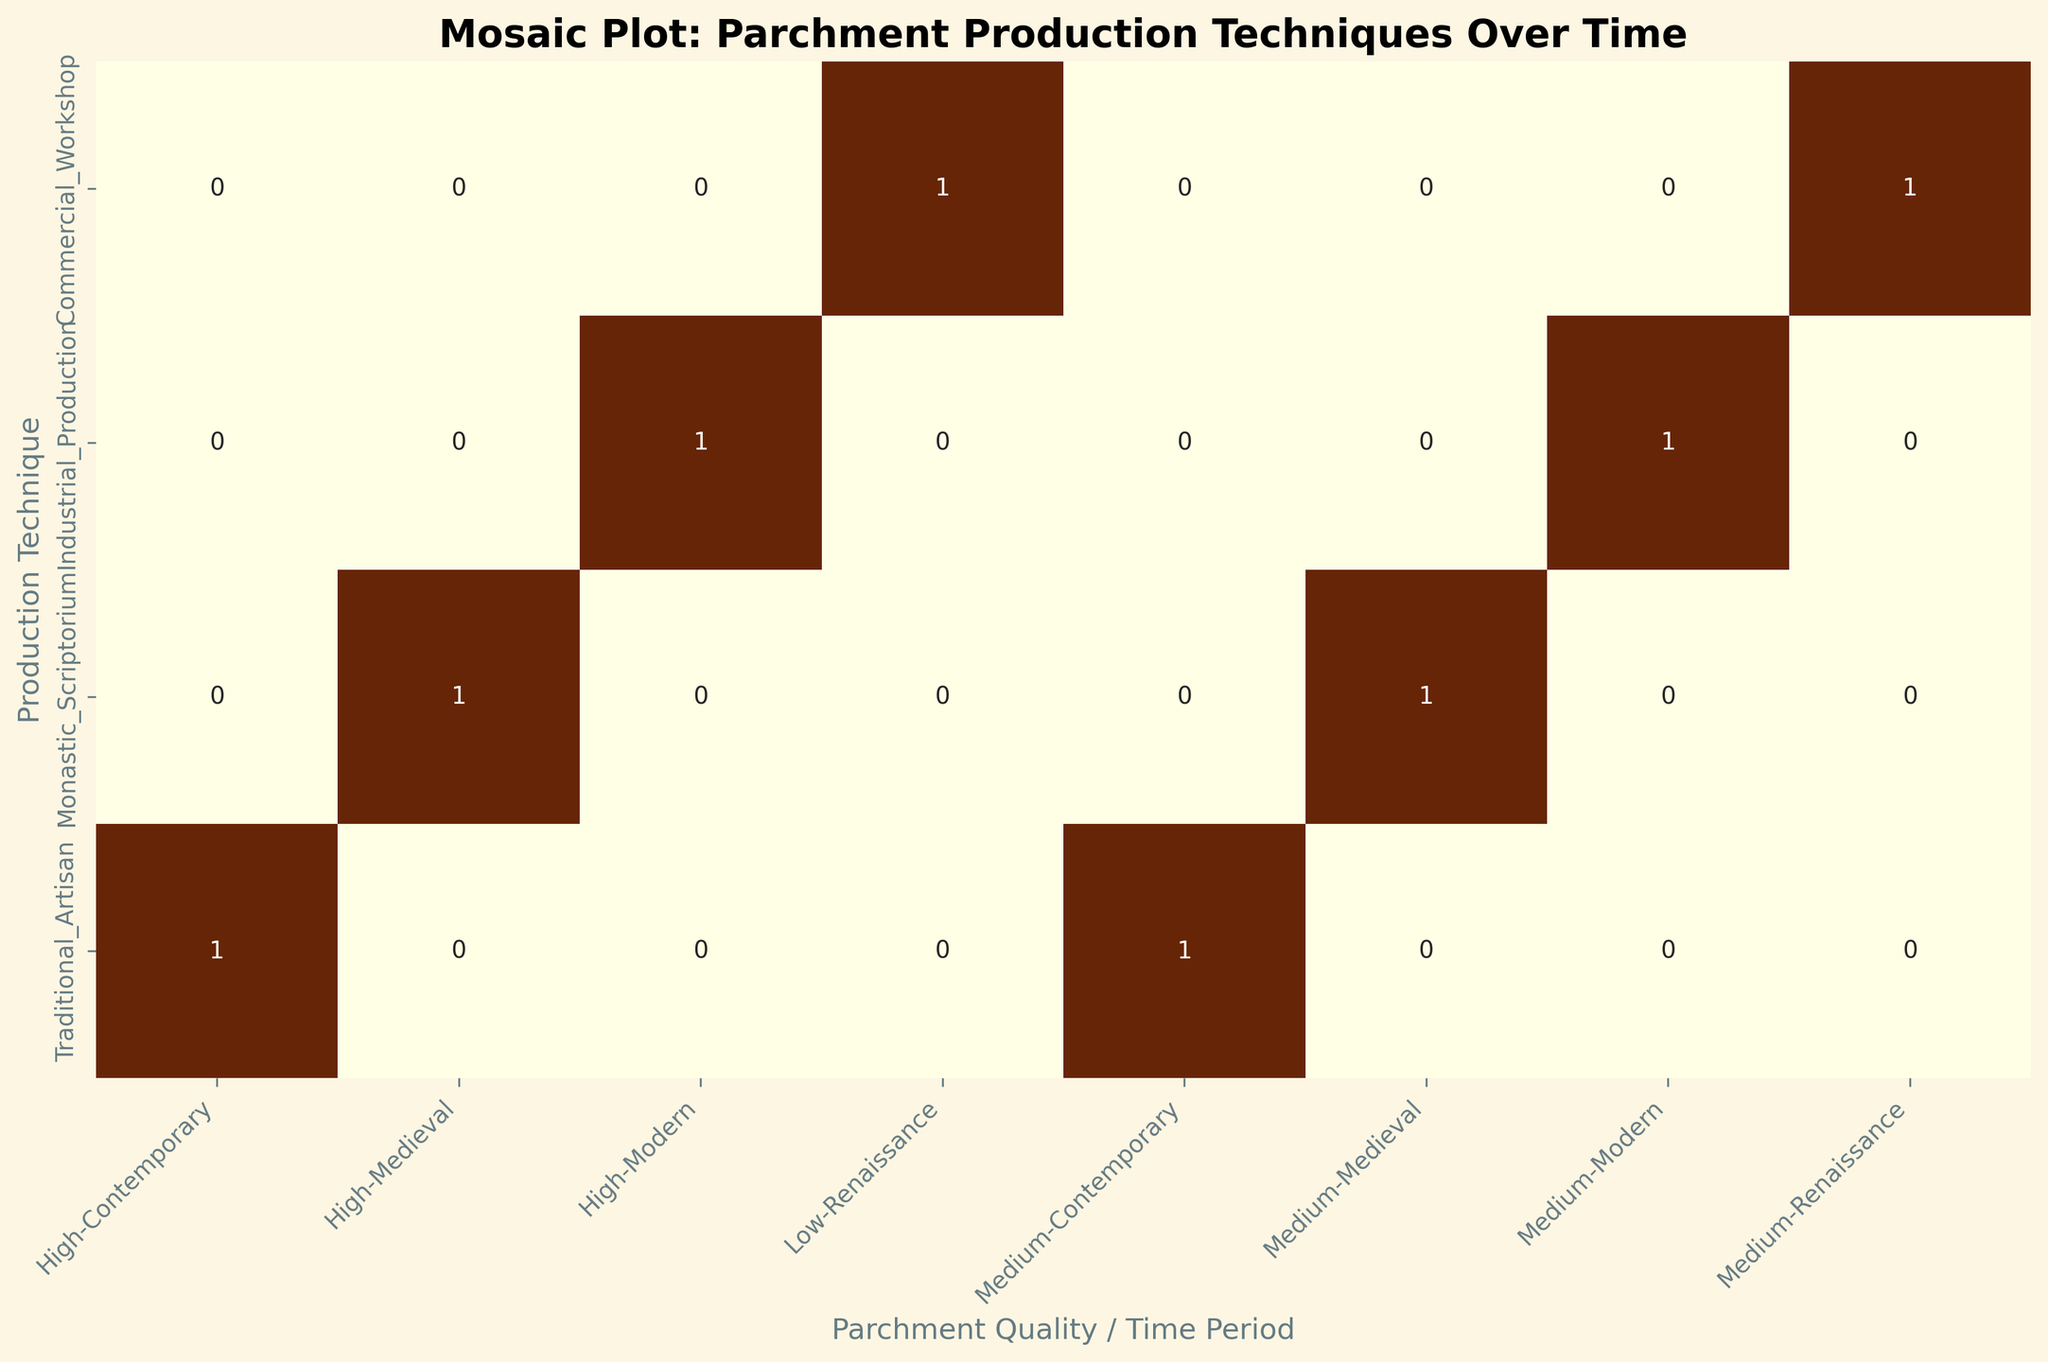How many instances of 'High' parchment quality are documented in the Medieval time period? Start by identifying the cells that correspond to 'High' parchment quality and the Medieval time period in the 'Parchment Quality / Time Period' axis. There is only one such cell under 'Monastic_Scriptorium' with a documented count.
Answer: 25 Which production technique during the Modern time period has the highest count of parchment? Identify the cells under the Modern time period segment. Compare the counts for each production technique listed: 'Industrial_Production' with 40 and 35 as the counts. The highest count is from 'Temperature_Control' which is 40.
Answer: Industrial_Production How does the number of 'Medium' parchment quality items produced by Commercial_Workshop compare between the Renaissance and Modern periods? Locate the cells for 'Medium' parchment quality under 'Commercial_Workshop'. For Renaissance, count is 30 and for Modern, there is no entry under Commercial_Workshop. Therefore, the Renaissance period has a higher count for this category.
Answer: 30 vs 0 What is the total count of parchments with 'Low' quality in Renaissance time period? There is one cell for 'Low' parchment quality in Renaissance: 'Commercial_Workshop' counts 15. Summing these counts results in 15.
Answer: 15 What preservation method has the maximum count in the Contemporary period for 'Medium' parchment quality? Locate cells under the 'Contemporary' time period and 'Medium' parchment quality. There is only one cell under 'Traditional_Artisan' with Humidity_Control holding a count of 20.
Answer: Humidity_Control Which time period has the highest overall count of high-quality parchments? Compare the counts for 'High' parchment quality across all time periods: Medieval (25), Modern (40), and Contemporary (12). Modern has the highest count.
Answer: Modern If you add the counts for Monastic_Scriptorium and Commercial_Workshop techniques for Medium parchment quality, what is the sum? Locate the cells for 'Monastic_Scriptorium' (18) and 'Commercial_Workshop' (30) under 'Medium' parchment quality. Sum these counts: 18 + 30 = 48.
Answer: 48 Which preservation method used in the Modern period for Medium parchment quality has count higher than 30? Locate cells under 'Medium' parchment quality and 'Modern'. Compare 'Deacidification' with 35 being higher than 30.
Answer: Deacidification What is the difference in counts between High and Medium quality parchments produced via Traditional_Artisan technique in Contemporary period? Identify the cells: High quality (12) and Medium quality (20). Calculate the difference: 20 - 12 = 8.
Answer: 8 